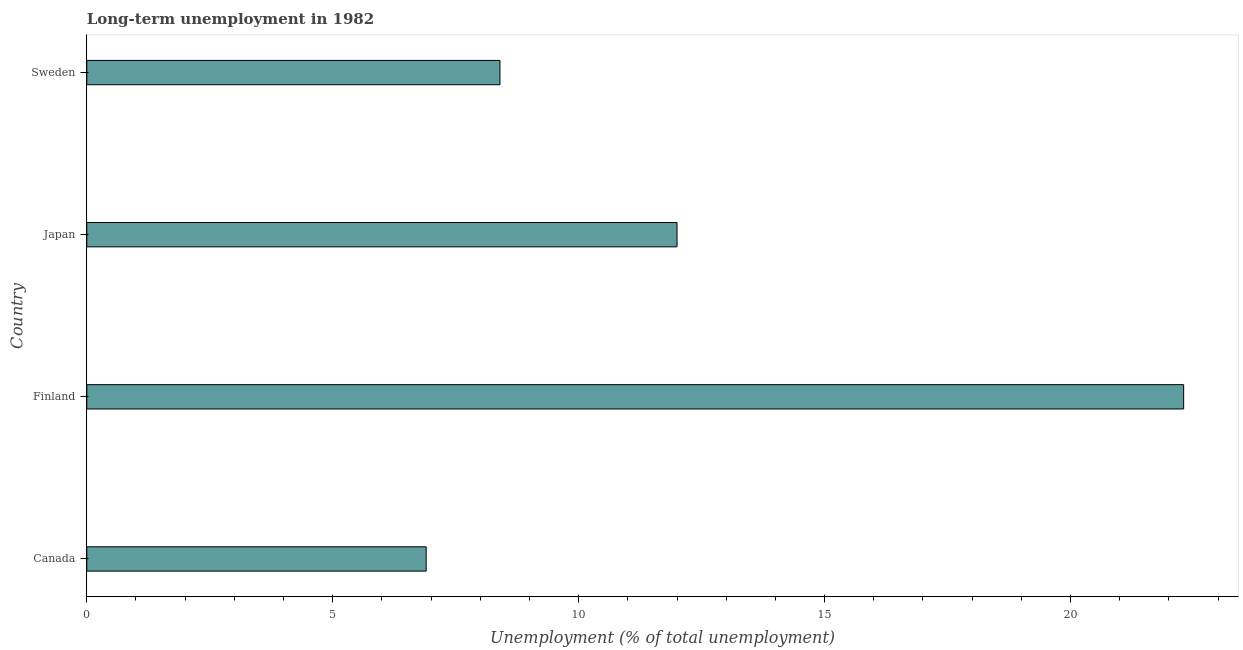Does the graph contain any zero values?
Ensure brevity in your answer.  No. Does the graph contain grids?
Provide a short and direct response. No. What is the title of the graph?
Provide a succinct answer. Long-term unemployment in 1982. What is the label or title of the X-axis?
Give a very brief answer. Unemployment (% of total unemployment). What is the long-term unemployment in Sweden?
Offer a terse response. 8.4. Across all countries, what is the maximum long-term unemployment?
Keep it short and to the point. 22.3. Across all countries, what is the minimum long-term unemployment?
Keep it short and to the point. 6.9. What is the sum of the long-term unemployment?
Your answer should be compact. 49.6. What is the difference between the long-term unemployment in Canada and Finland?
Provide a succinct answer. -15.4. What is the median long-term unemployment?
Ensure brevity in your answer.  10.2. What is the ratio of the long-term unemployment in Finland to that in Japan?
Offer a very short reply. 1.86. Is the sum of the long-term unemployment in Canada and Sweden greater than the maximum long-term unemployment across all countries?
Make the answer very short. No. In how many countries, is the long-term unemployment greater than the average long-term unemployment taken over all countries?
Provide a short and direct response. 1. How many countries are there in the graph?
Give a very brief answer. 4. What is the difference between two consecutive major ticks on the X-axis?
Ensure brevity in your answer.  5. Are the values on the major ticks of X-axis written in scientific E-notation?
Your answer should be compact. No. What is the Unemployment (% of total unemployment) of Canada?
Give a very brief answer. 6.9. What is the Unemployment (% of total unemployment) in Finland?
Offer a terse response. 22.3. What is the Unemployment (% of total unemployment) of Sweden?
Give a very brief answer. 8.4. What is the difference between the Unemployment (% of total unemployment) in Canada and Finland?
Provide a short and direct response. -15.4. What is the difference between the Unemployment (% of total unemployment) in Canada and Japan?
Provide a short and direct response. -5.1. What is the ratio of the Unemployment (% of total unemployment) in Canada to that in Finland?
Make the answer very short. 0.31. What is the ratio of the Unemployment (% of total unemployment) in Canada to that in Japan?
Ensure brevity in your answer.  0.57. What is the ratio of the Unemployment (% of total unemployment) in Canada to that in Sweden?
Give a very brief answer. 0.82. What is the ratio of the Unemployment (% of total unemployment) in Finland to that in Japan?
Your answer should be very brief. 1.86. What is the ratio of the Unemployment (% of total unemployment) in Finland to that in Sweden?
Provide a succinct answer. 2.65. What is the ratio of the Unemployment (% of total unemployment) in Japan to that in Sweden?
Ensure brevity in your answer.  1.43. 